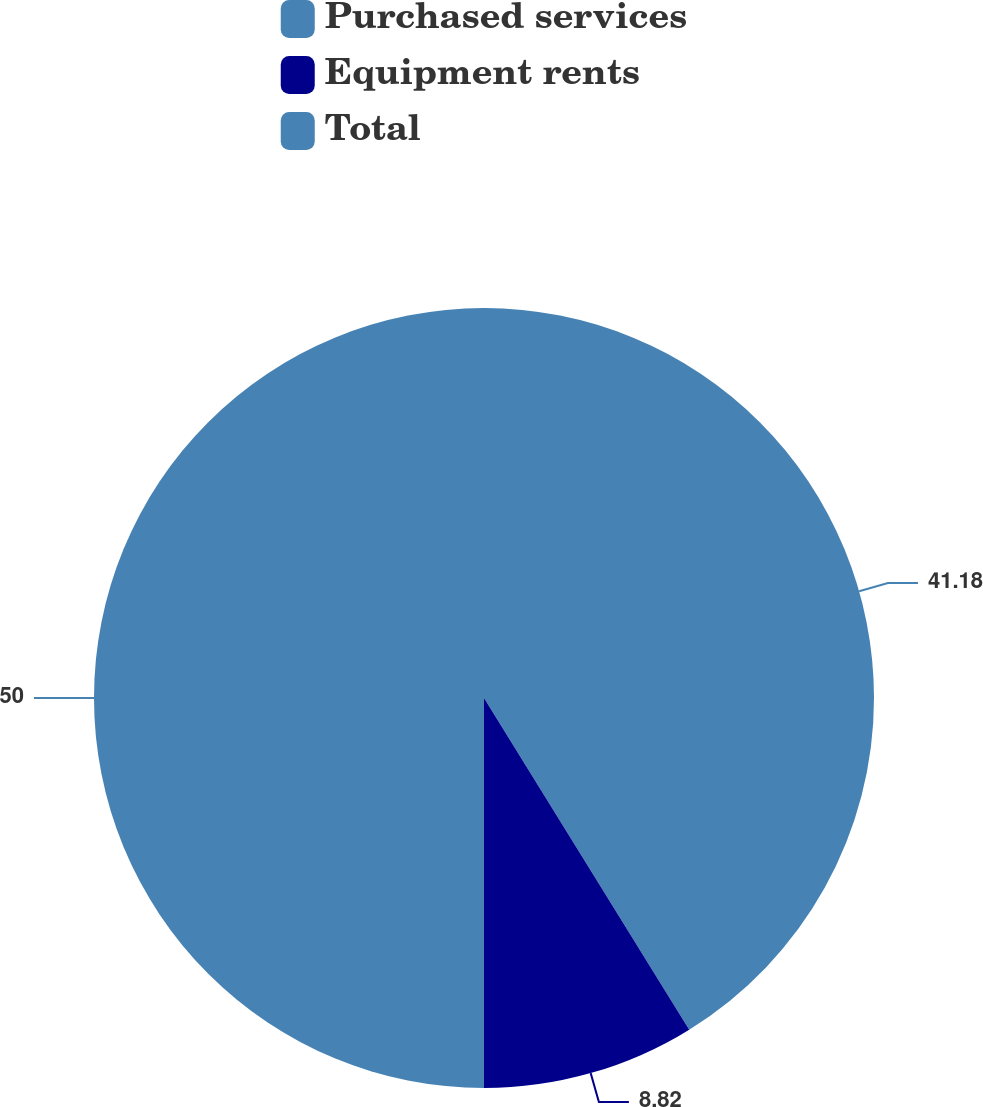<chart> <loc_0><loc_0><loc_500><loc_500><pie_chart><fcel>Purchased services<fcel>Equipment rents<fcel>Total<nl><fcel>41.18%<fcel>8.82%<fcel>50.0%<nl></chart> 